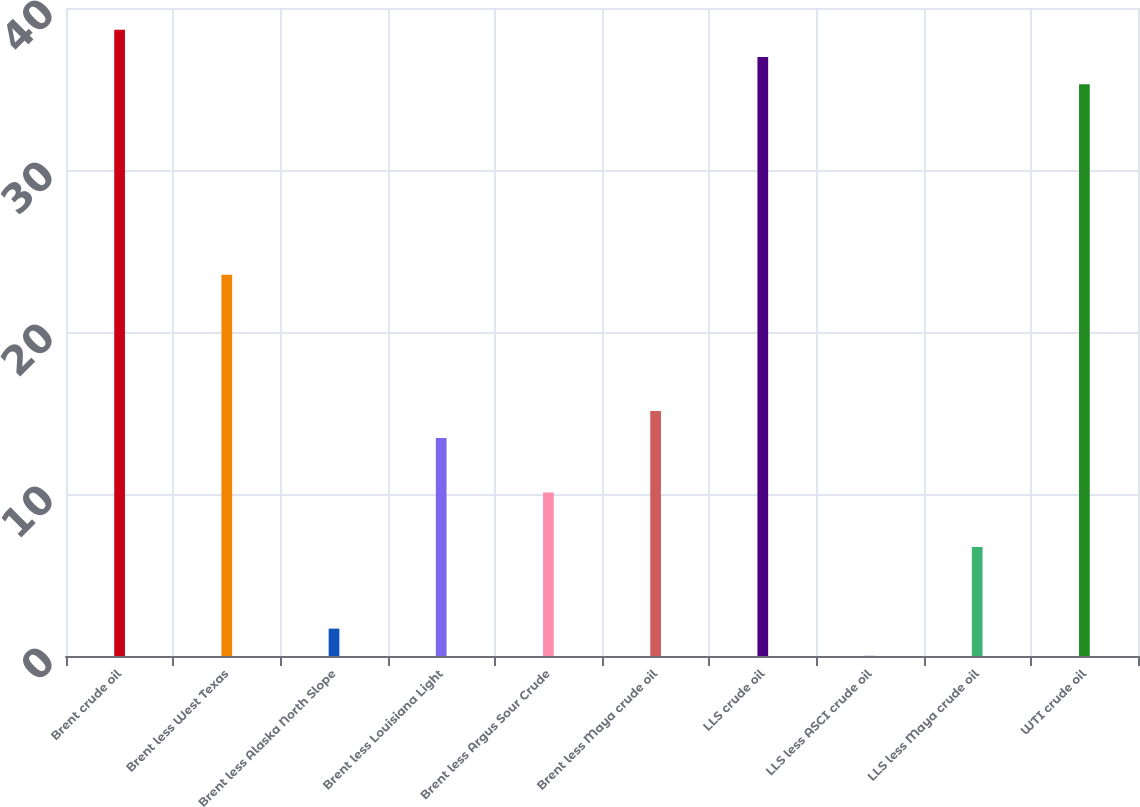<chart> <loc_0><loc_0><loc_500><loc_500><bar_chart><fcel>Brent crude oil<fcel>Brent less West Texas<fcel>Brent less Alaska North Slope<fcel>Brent less Louisiana Light<fcel>Brent less Argus Sour Crude<fcel>Brent less Maya crude oil<fcel>LLS crude oil<fcel>LLS less ASCI crude oil<fcel>LLS less Maya crude oil<fcel>WTI crude oil<nl><fcel>38.65<fcel>23.53<fcel>1.69<fcel>13.45<fcel>10.09<fcel>15.13<fcel>36.97<fcel>0.01<fcel>6.73<fcel>35.29<nl></chart> 